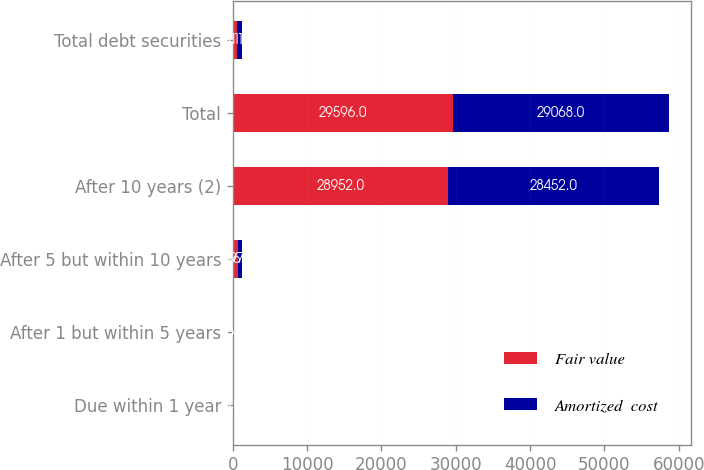Convert chart. <chart><loc_0><loc_0><loc_500><loc_500><stacked_bar_chart><ecel><fcel>Due within 1 year<fcel>After 1 but within 5 years<fcel>After 5 but within 10 years<fcel>After 10 years (2)<fcel>Total<fcel>Total debt securities<nl><fcel>Fair value<fcel>2<fcel>16<fcel>626<fcel>28952<fcel>29596<fcel>611.5<nl><fcel>Amortized  cost<fcel>3<fcel>16<fcel>597<fcel>28452<fcel>29068<fcel>611.5<nl></chart> 